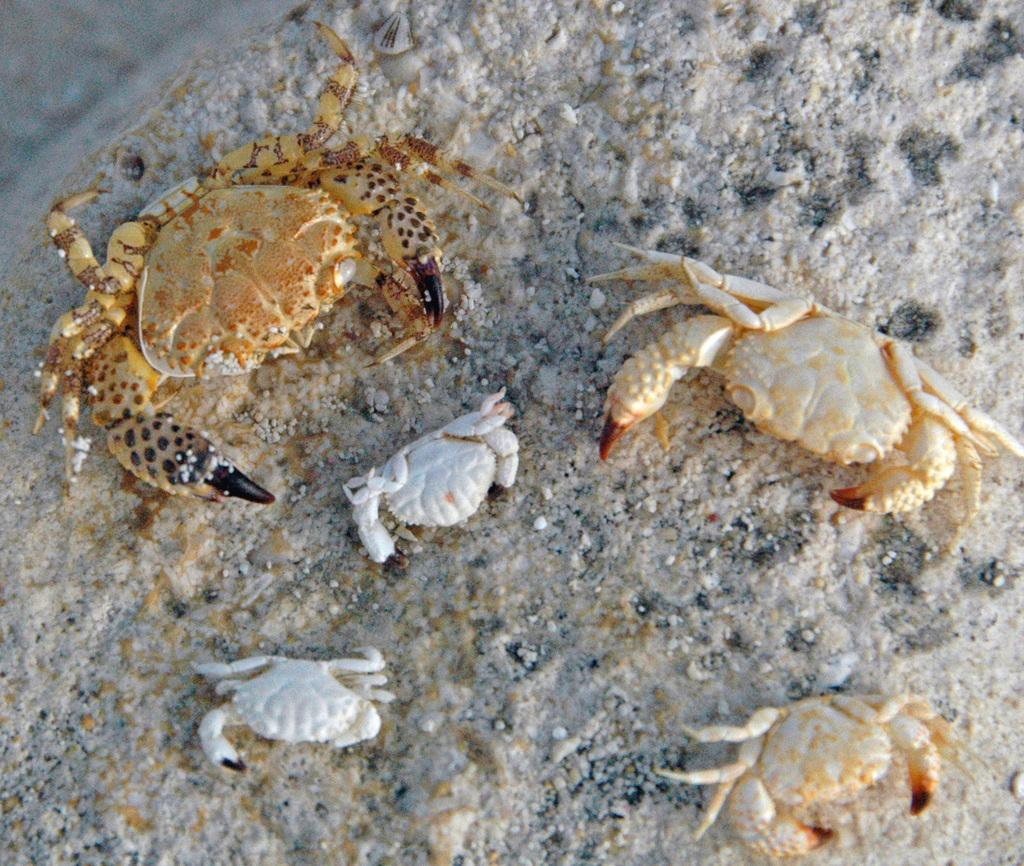What type of animals are present in the image? There are scorpions in the image. What can be seen in the background of the image? There is a wall in the background of the image. How does the rainstorm affect the acoustics of the cars in the image? There are no cars or rainstorm present in the image; it features scorpions and a wall. 